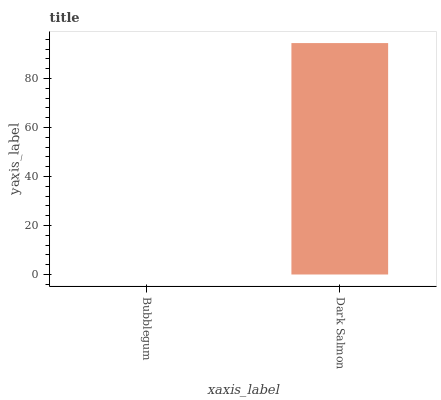Is Bubblegum the minimum?
Answer yes or no. Yes. Is Dark Salmon the maximum?
Answer yes or no. Yes. Is Dark Salmon the minimum?
Answer yes or no. No. Is Dark Salmon greater than Bubblegum?
Answer yes or no. Yes. Is Bubblegum less than Dark Salmon?
Answer yes or no. Yes. Is Bubblegum greater than Dark Salmon?
Answer yes or no. No. Is Dark Salmon less than Bubblegum?
Answer yes or no. No. Is Dark Salmon the high median?
Answer yes or no. Yes. Is Bubblegum the low median?
Answer yes or no. Yes. Is Bubblegum the high median?
Answer yes or no. No. Is Dark Salmon the low median?
Answer yes or no. No. 